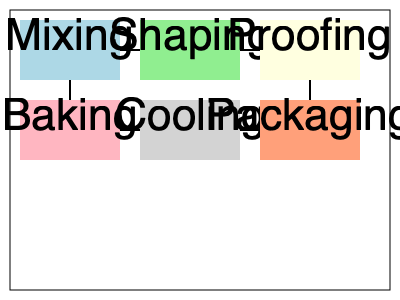Based on the given bakery floor plan, which production line layout would be most efficient for maximizing output and minimizing product movement? To determine the most efficient production line layout, we need to consider the following factors:

1. Process flow: The ideal layout should follow the natural progression of the baking process.
2. Minimizing movement: Products should move as little as possible between stages to reduce handling and potential damage.
3. Continuous flow: The layout should allow for a continuous, uninterrupted flow of products.

Analyzing the floor plan:

1. The process starts with mixing, followed by shaping and proofing in the top row.
2. The bottom row shows baking, cooling, and packaging.
3. The arrows indicate the current flow of products between stations.

The most efficient layout would be:

1. Mixing → Shaping → Proofing (top row, left to right)
2. Proofing → Baking (moving down)
3. Baking → Cooling → Packaging (bottom row, left to right)

This layout creates a U-shaped flow, which is optimal for several reasons:
- It follows the natural progression of the baking process.
- It minimizes the distance products need to travel between stages.
- It allows for a continuous flow without backtracking or crossing paths.
- It maximizes the use of space and reduces the potential for bottlenecks.

The U-shaped layout also facilitates easier supervision and management of the entire process, as well as potential for future automation implementations.
Answer: U-shaped flow 